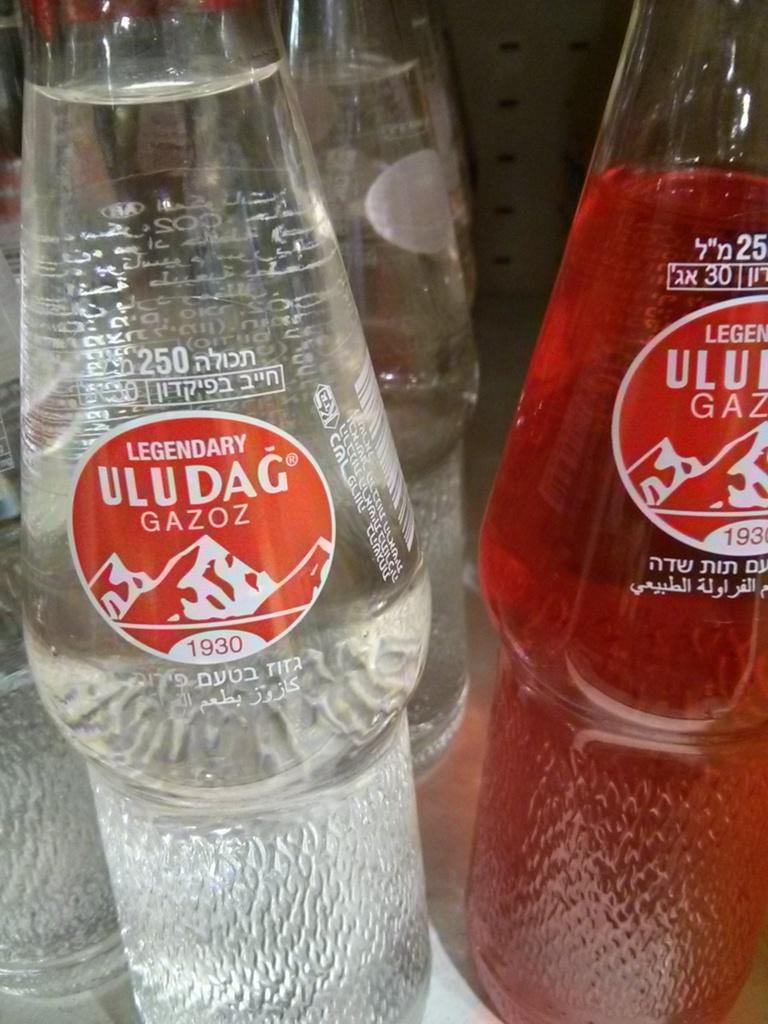Please provide a concise description of this image. There are two soft drink bottles with transparent liquid in left side bottle and red color liquid in right side bottle and behind there are other similar bottles. 